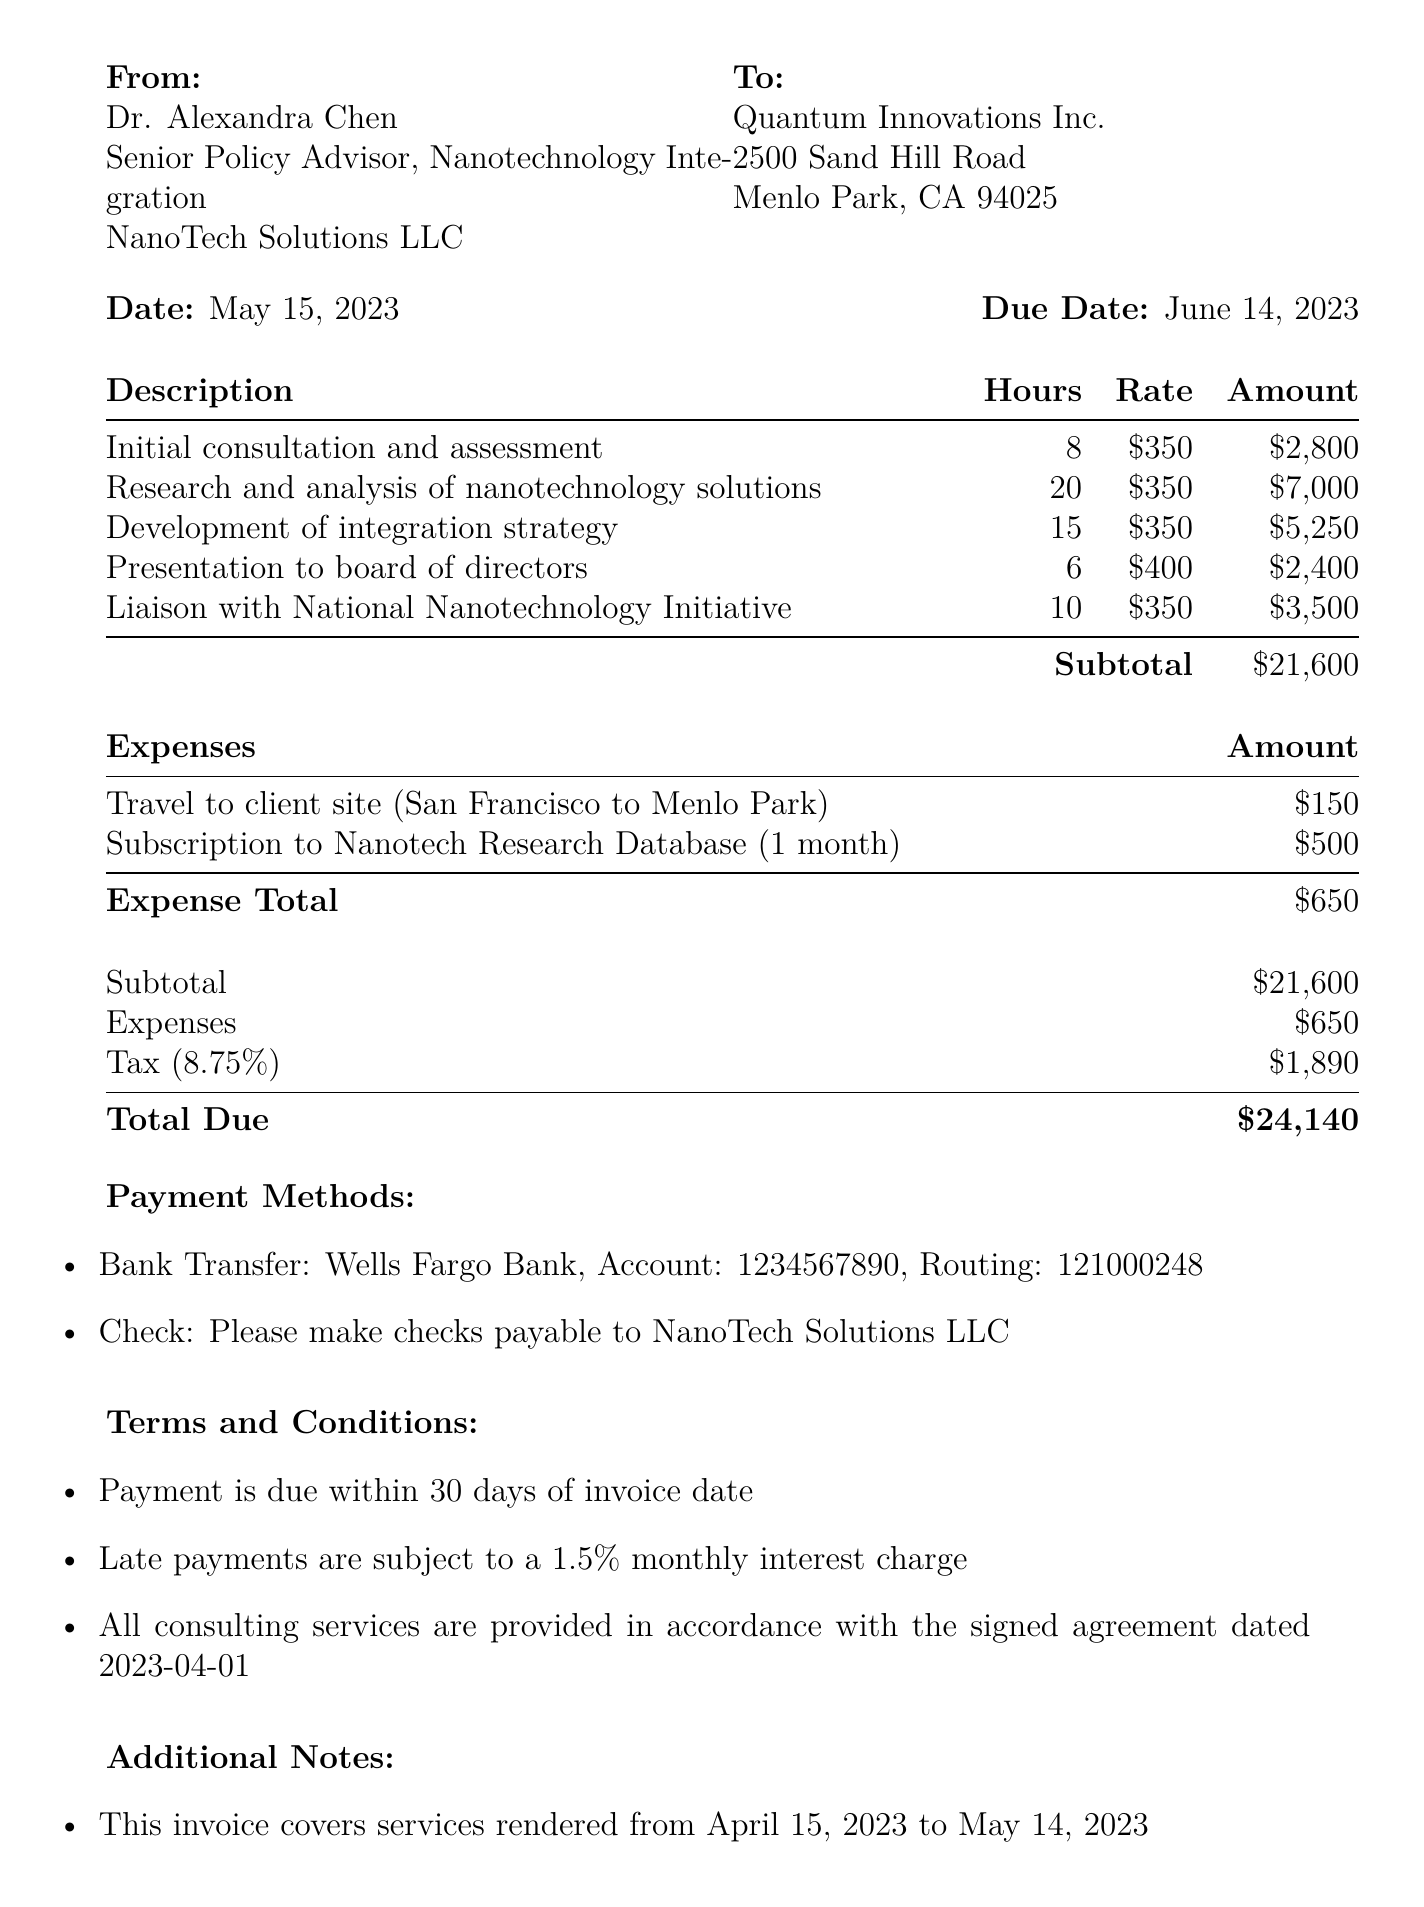What is the invoice number? The invoice number can be found in the header of the document.
Answer: INV-2023-0542 Who is the consultant? The consultant's name is listed at the top of the document under "From."
Answer: Dr. Alexandra Chen What is the total amount due? The total due is calculated at the bottom of the invoice.
Answer: $24,140 How many hours were spent on research and analysis? The hours for research and analysis can be found in the services section.
Answer: 20 What is the subtotal before tax? The subtotal can be found in the payment details section.
Answer: $21,600 What is the tax rate applied to the invoice? The tax rate is specified in the payment details section.
Answer: 8.75% What date was the invoice issued? The issue date is indicated near the top of the invoice.
Answer: May 15, 2023 What type of services are provided? The services are outlined in the services section with descriptions.
Answer: Consulting services What expenses were incurred? The document lists the expenses under a specific section, detailing what was incurred.
Answer: Travel to client site, Subscription to Nanotech Research Database What is the payment method for the invoice? Payment methods are listed in a specific section of the document.
Answer: Bank Transfer, Check 